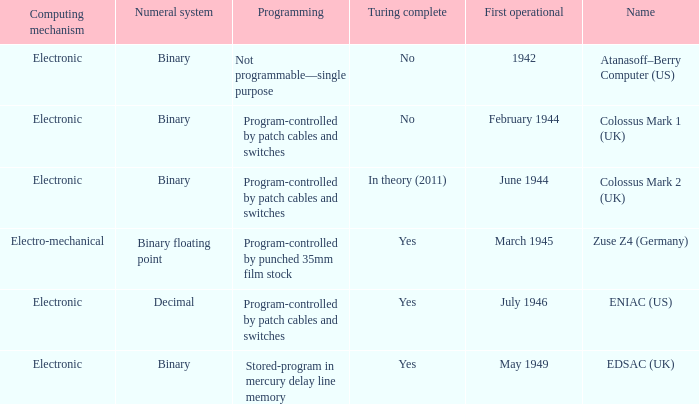What's the name with first operational being march 1945 Zuse Z4 (Germany). 